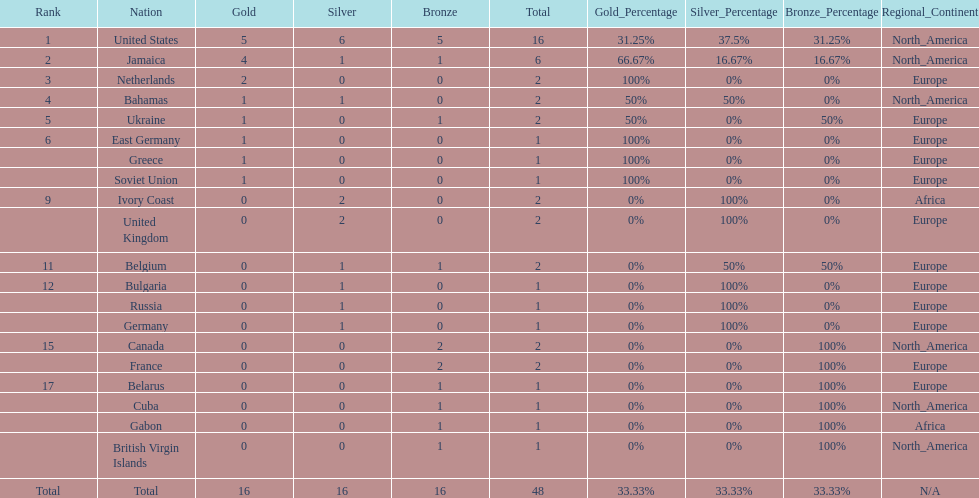What country won more gold medals than any other? United States. 